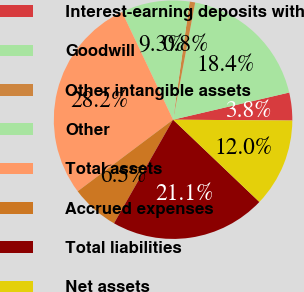<chart> <loc_0><loc_0><loc_500><loc_500><pie_chart><fcel>Interest-earning deposits with<fcel>Goodwill<fcel>Other intangible assets<fcel>Other<fcel>Total assets<fcel>Accrued expenses<fcel>Total liabilities<fcel>Net assets<nl><fcel>3.77%<fcel>18.37%<fcel>0.75%<fcel>9.26%<fcel>28.2%<fcel>6.51%<fcel>21.12%<fcel>12.0%<nl></chart> 